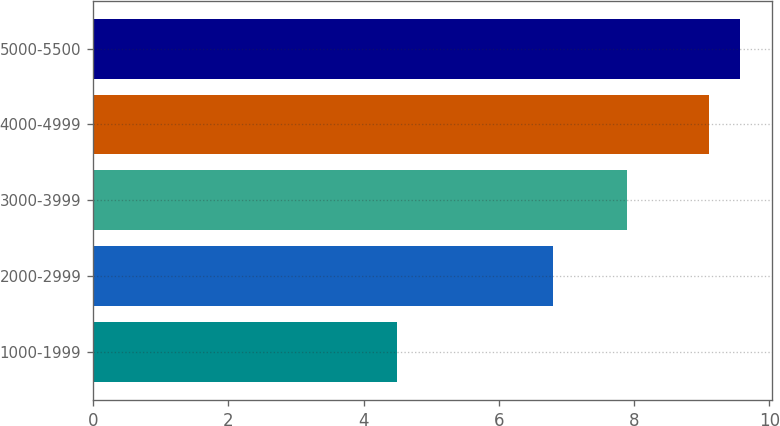Convert chart. <chart><loc_0><loc_0><loc_500><loc_500><bar_chart><fcel>1000-1999<fcel>2000-2999<fcel>3000-3999<fcel>4000-4999<fcel>5000-5500<nl><fcel>4.5<fcel>6.8<fcel>7.9<fcel>9.1<fcel>9.56<nl></chart> 